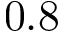<formula> <loc_0><loc_0><loc_500><loc_500>0 . 8</formula> 